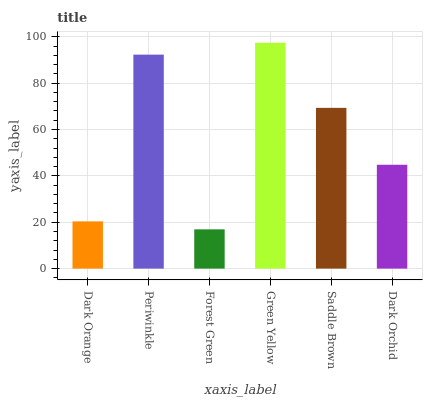Is Periwinkle the minimum?
Answer yes or no. No. Is Periwinkle the maximum?
Answer yes or no. No. Is Periwinkle greater than Dark Orange?
Answer yes or no. Yes. Is Dark Orange less than Periwinkle?
Answer yes or no. Yes. Is Dark Orange greater than Periwinkle?
Answer yes or no. No. Is Periwinkle less than Dark Orange?
Answer yes or no. No. Is Saddle Brown the high median?
Answer yes or no. Yes. Is Dark Orchid the low median?
Answer yes or no. Yes. Is Green Yellow the high median?
Answer yes or no. No. Is Saddle Brown the low median?
Answer yes or no. No. 